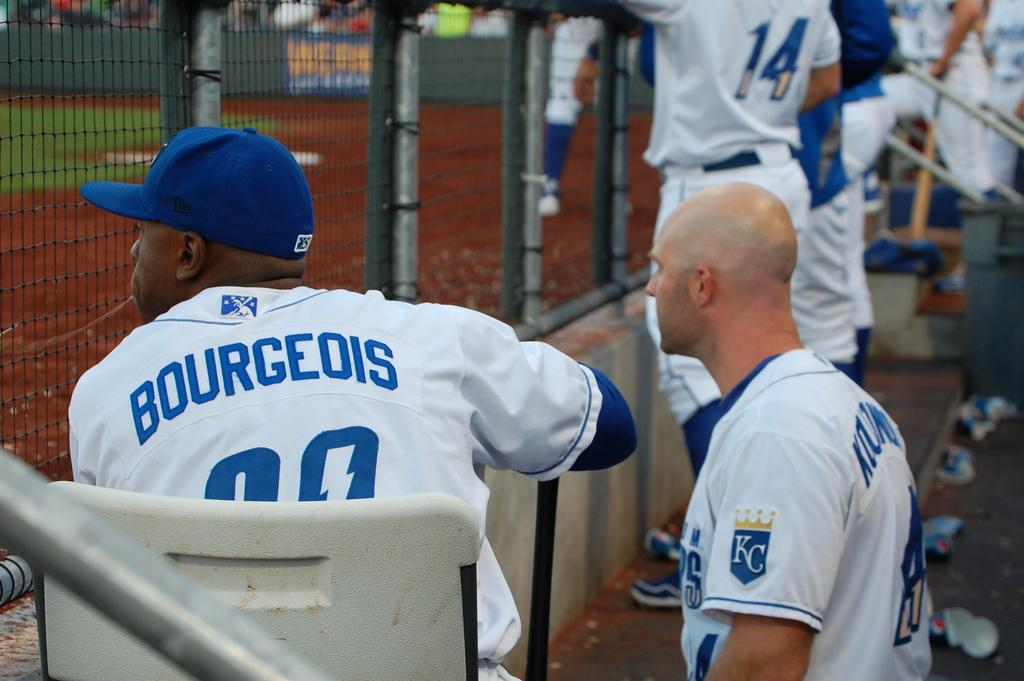Provide a one-sentence caption for the provided image. Players are seen sitting in the KC dugout. 